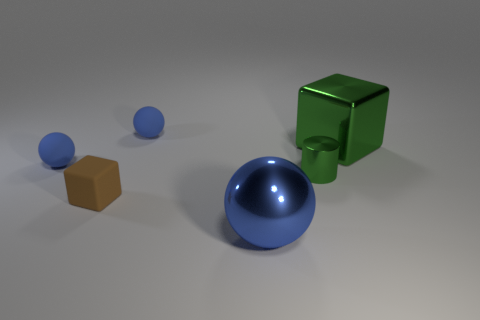There is a shiny block that is the same color as the tiny cylinder; what size is it?
Your answer should be very brief. Large. The large metal object that is the same color as the cylinder is what shape?
Your answer should be compact. Cube. There is a blue metal object that is the same size as the green cube; what is its shape?
Your answer should be very brief. Sphere. How many things are tiny yellow metallic balls or tiny matte objects?
Provide a succinct answer. 3. There is a large shiny thing in front of the small green thing; does it have the same shape as the thing behind the green shiny block?
Provide a short and direct response. Yes. What shape is the big object that is behind the brown cube?
Make the answer very short. Cube. Are there the same number of blue rubber things that are in front of the tiny green thing and spheres on the right side of the large blue metallic object?
Provide a succinct answer. Yes. How many objects are either cyan metallic objects or large objects that are to the left of the small metallic object?
Provide a short and direct response. 1. What shape is the object that is both on the right side of the brown matte object and in front of the green metallic cylinder?
Your answer should be compact. Sphere. What material is the tiny ball behind the rubber thing on the left side of the tiny brown object?
Offer a terse response. Rubber. 